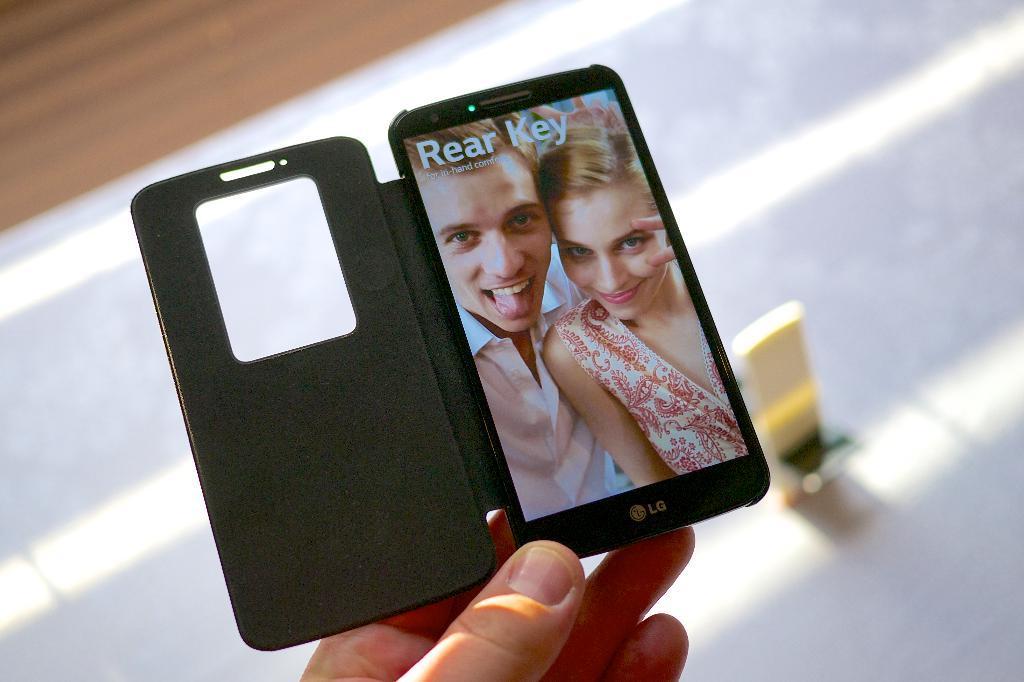Please provide a concise description of this image. In the picture I can see the hand of a person holding the mobile phone. 